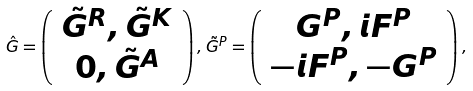Convert formula to latex. <formula><loc_0><loc_0><loc_500><loc_500>\hat { G } = \left ( \begin{array} { c c } \tilde { G } ^ { R } , \tilde { G } ^ { K } \\ 0 , \tilde { G } ^ { A } \end{array} \right ) , \tilde { G } ^ { P } = \left ( \begin{array} { c c } G ^ { P } , i F ^ { P } \\ - i F ^ { P } , - G ^ { P } \end{array} \right ) ,</formula> 